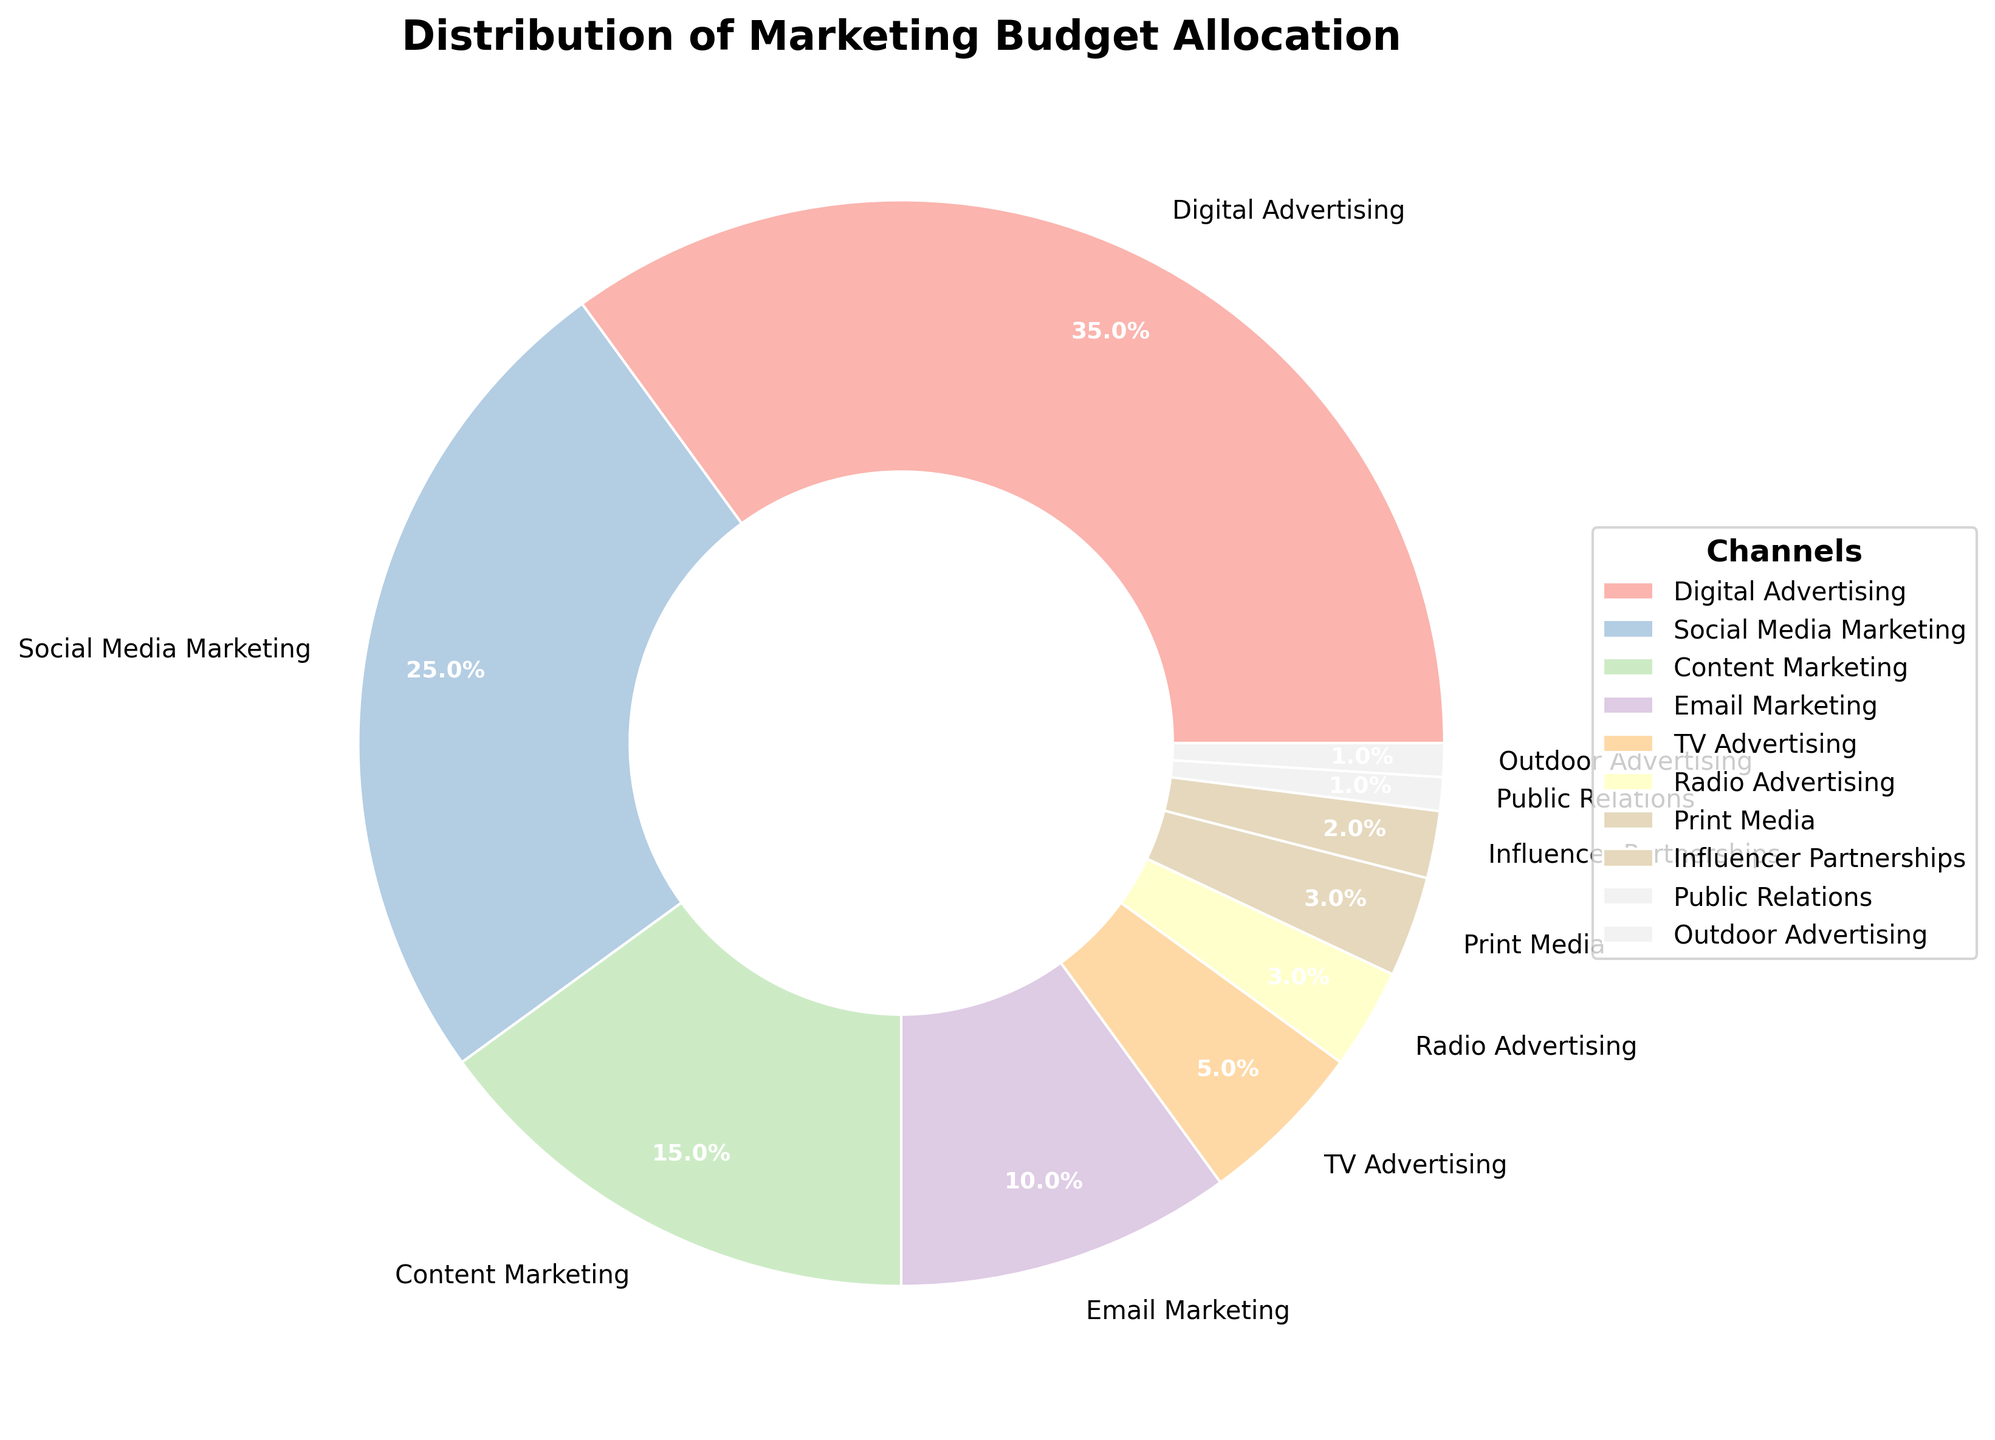Which channel has the largest allocation of the marketing budget? The pie chart shows that Digital Advertising has the largest allocation.
Answer: Digital Advertising What is the combined percentage of the budget for Social Media Marketing and Email Marketing? Social Media Marketing has 25% and Email Marketing has 10%. Summing them up, 25% + 10% = 35%.
Answer: 35% Which channel has a lower budget allocation, Radio Advertising or Print Media? The pie chart shows that both Radio Advertising and Print Media have the same budget allocation of 3%.
Answer: Equal What is the total percentage of the budget allocated to channels other than Digital Advertising? Digital Advertising has 35%, so the remaining budget is 100% - 35% = 65%.
Answer: 65% What is the percentage difference between Content Marketing and Public Relations? Content Marketing has 15% and Public Relations has 1%. The difference is 15% - 1% = 14%.
Answer: 14% What is the median value of the budget allocations across all channels? The ordered percentages are 1, 1, 2, 3, 3, 5, 10, 15, 25, 35. Since there are an even number of data points (10), the median is the average of the 5th and 6th values, which are 3 and 5. Thus, (3 + 5)/2 = 4%.
Answer: 4% What channels have an allocation of less than 5% of the budget? The pie chart shows that TV Advertising (5%), Radio Advertising (3%), Print Media (3%), Influencer Partnerships (2%), Public Relations (1%), and Outdoor Advertising (1%) are below 5%.
Answer: TV Advertising, Radio Advertising, Print Media, Influencer Partnerships, Public Relations, Outdoor Advertising If we combine the allocations for TV Advertising, Radio Advertising, and Print Media, what is the total percentage? TV Advertising is 5%, Radio Advertising is 3%, and Print Media is 3%. Adding them together gives 5% + 3% + 3% = 11%.
Answer: 11% Is the percentage of the budget for Content Marketing greater than the combined percentage of Public Relations and Outdoor Advertising? Content Marketing has 15%. Public Relations and Outdoor Advertising together have 1% + 1% = 2%. 15% is greater than 2%.
Answer: Yes What are the two smallest budget allocations? The pie chart shows that Public Relations and Outdoor Advertising have the smallest allocations at 1% each.
Answer: Public Relations, Outdoor Advertising 